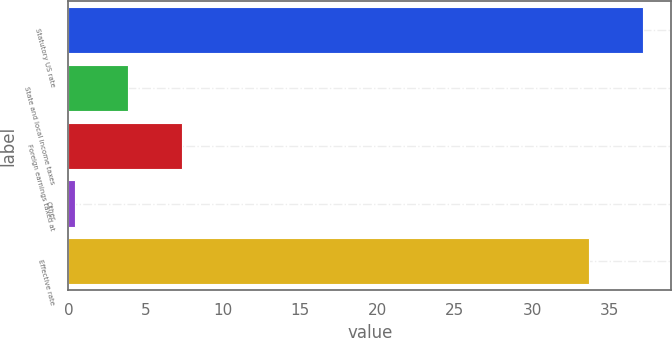<chart> <loc_0><loc_0><loc_500><loc_500><bar_chart><fcel>Statutory US rate<fcel>State and local income taxes<fcel>Foreign earnings taxed at<fcel>Other<fcel>Effective rate<nl><fcel>37.16<fcel>3.86<fcel>7.32<fcel>0.4<fcel>33.7<nl></chart> 